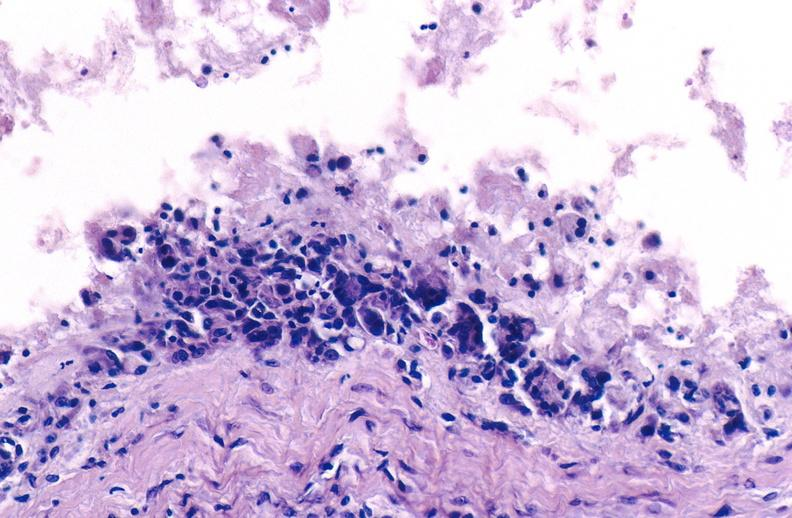s joints present?
Answer the question using a single word or phrase. Yes 